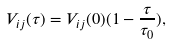Convert formula to latex. <formula><loc_0><loc_0><loc_500><loc_500>V _ { i j } ( \tau ) = V _ { i j } ( 0 ) ( 1 - { \frac { \tau } { \tau _ { 0 } } } ) ,</formula> 